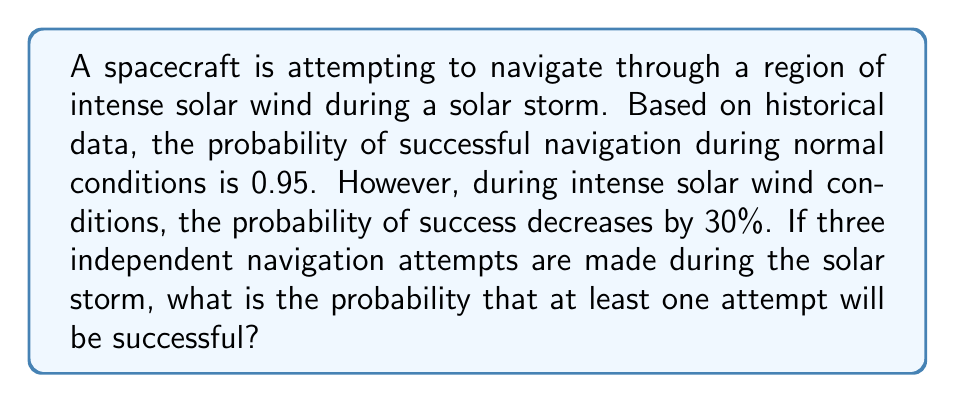Show me your answer to this math problem. Let's approach this step-by-step:

1) First, we need to calculate the probability of successful navigation during intense solar wind conditions:
   Normal probability: 0.95
   Decrease: 30% = 0.30
   New probability: $0.95 - (0.95 \times 0.30) = 0.95 - 0.285 = 0.665$

2) Now, we need to find the probability of at least one successful attempt out of three independent tries. It's often easier to calculate the probability of the complement event (no successful attempts) and then subtract from 1.

3) Probability of failure in one attempt: $1 - 0.665 = 0.335$

4) Probability of failure in all three attempts:
   $P(\text{all failures}) = 0.335 \times 0.335 \times 0.335 = 0.335^3 \approx 0.0376$

5) Therefore, the probability of at least one success is:
   $P(\text{at least one success}) = 1 - P(\text{all failures}) = 1 - 0.0376 = 0.9624$

6) This can be expressed as a percentage: $0.9624 \times 100\% = 96.24\%$
Answer: $96.24\%$ 